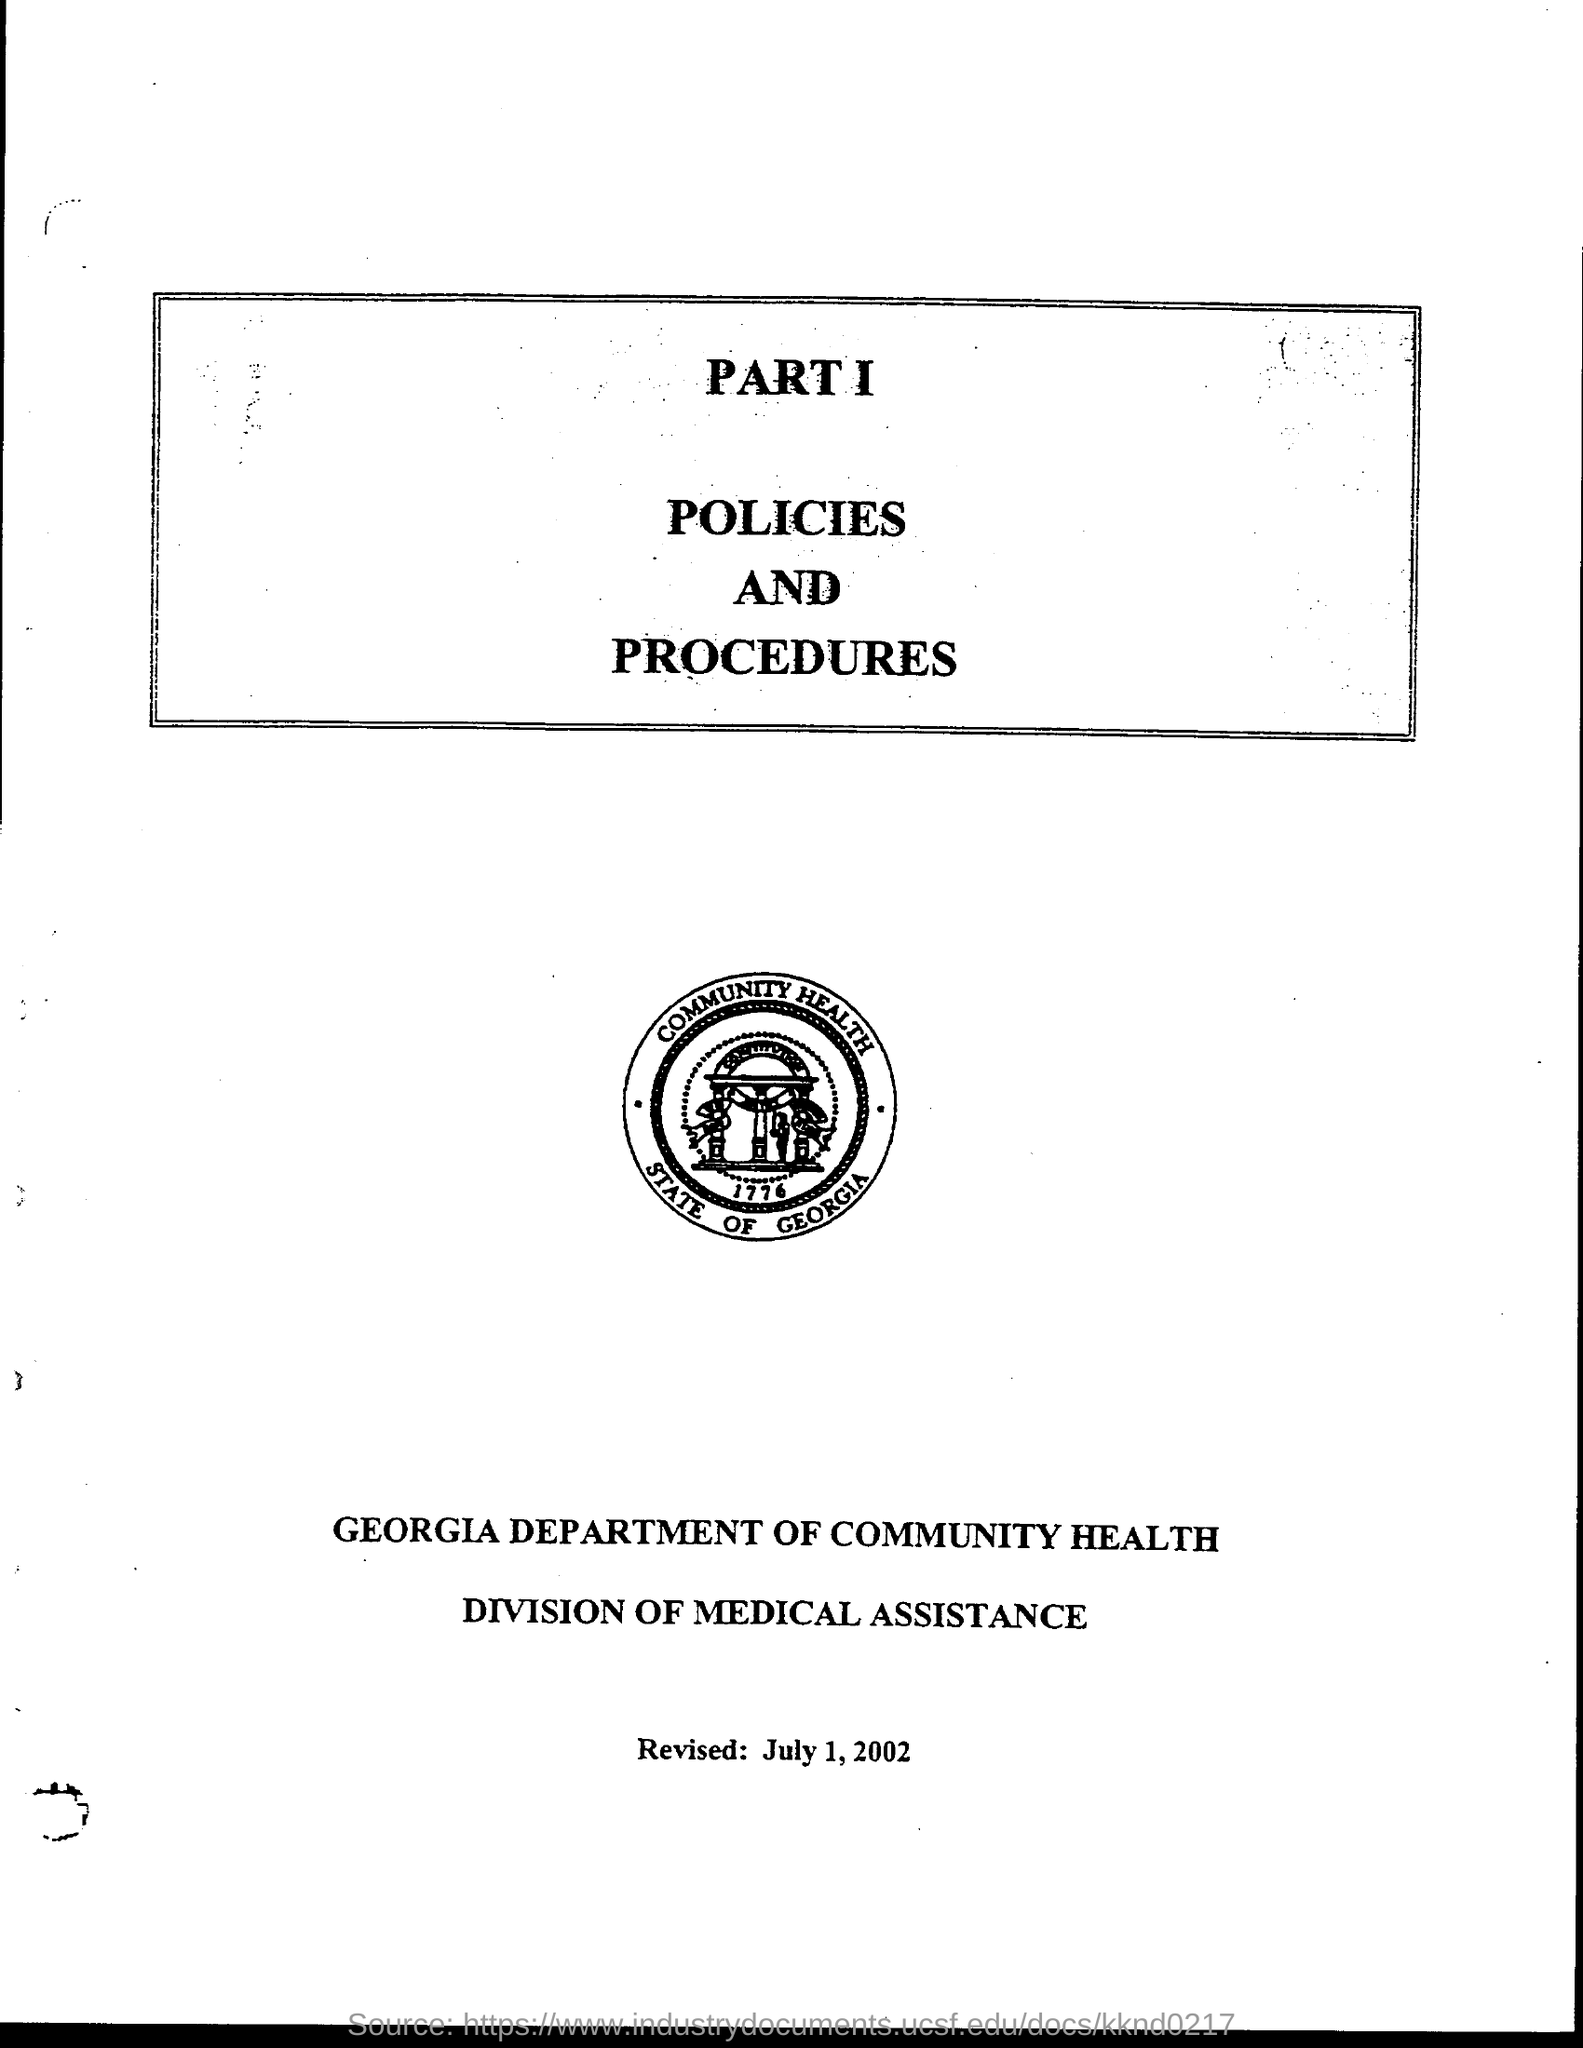Point out several critical features in this image. The revised date is July 1, 2002. The department is the department of community health. The seal features the year 1776, written in a round shape. 